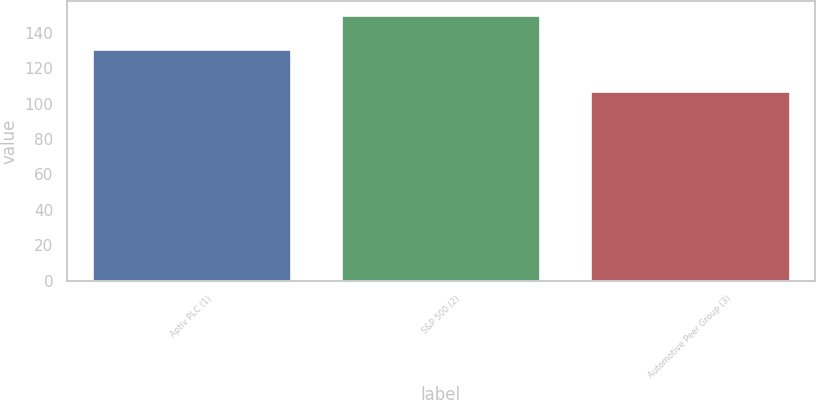<chart> <loc_0><loc_0><loc_500><loc_500><bar_chart><fcel>Aptiv PLC (1)<fcel>S&P 500 (2)<fcel>Automotive Peer Group (3)<nl><fcel>130.8<fcel>150.33<fcel>106.89<nl></chart> 